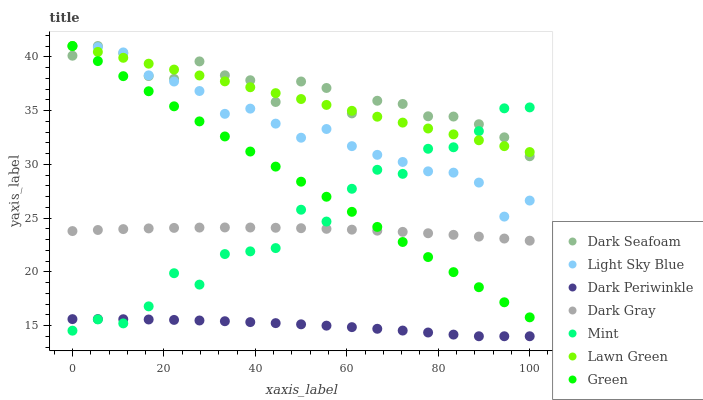Does Dark Periwinkle have the minimum area under the curve?
Answer yes or no. Yes. Does Dark Seafoam have the maximum area under the curve?
Answer yes or no. Yes. Does Dark Gray have the minimum area under the curve?
Answer yes or no. No. Does Dark Gray have the maximum area under the curve?
Answer yes or no. No. Is Lawn Green the smoothest?
Answer yes or no. Yes. Is Mint the roughest?
Answer yes or no. Yes. Is Dark Gray the smoothest?
Answer yes or no. No. Is Dark Gray the roughest?
Answer yes or no. No. Does Dark Periwinkle have the lowest value?
Answer yes or no. Yes. Does Dark Gray have the lowest value?
Answer yes or no. No. Does Green have the highest value?
Answer yes or no. Yes. Does Dark Gray have the highest value?
Answer yes or no. No. Is Dark Periwinkle less than Lawn Green?
Answer yes or no. Yes. Is Dark Seafoam greater than Dark Periwinkle?
Answer yes or no. Yes. Does Dark Periwinkle intersect Mint?
Answer yes or no. Yes. Is Dark Periwinkle less than Mint?
Answer yes or no. No. Is Dark Periwinkle greater than Mint?
Answer yes or no. No. Does Dark Periwinkle intersect Lawn Green?
Answer yes or no. No. 